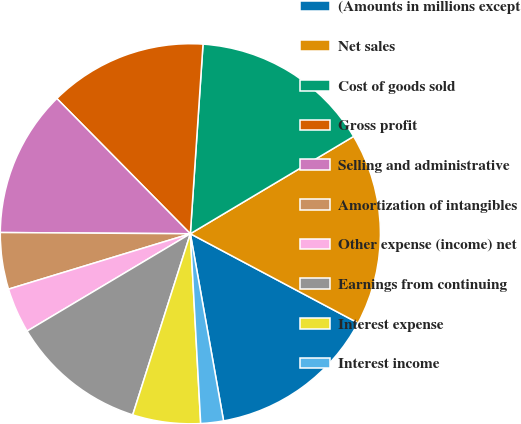Convert chart. <chart><loc_0><loc_0><loc_500><loc_500><pie_chart><fcel>(Amounts in millions except<fcel>Net sales<fcel>Cost of goods sold<fcel>Gross profit<fcel>Selling and administrative<fcel>Amortization of intangibles<fcel>Other expense (income) net<fcel>Earnings from continuing<fcel>Interest expense<fcel>Interest income<nl><fcel>14.42%<fcel>16.34%<fcel>15.38%<fcel>13.46%<fcel>12.5%<fcel>4.81%<fcel>3.85%<fcel>11.54%<fcel>5.77%<fcel>1.93%<nl></chart> 